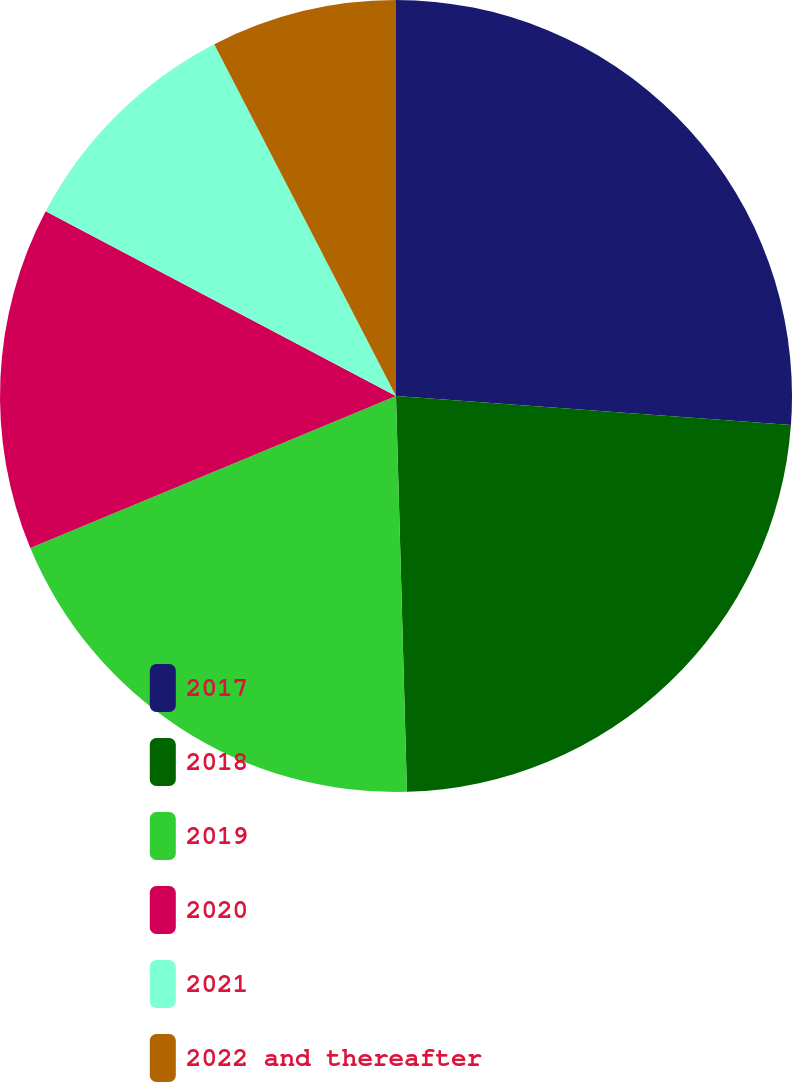Convert chart to OTSL. <chart><loc_0><loc_0><loc_500><loc_500><pie_chart><fcel>2017<fcel>2018<fcel>2019<fcel>2020<fcel>2021<fcel>2022 and thereafter<nl><fcel>26.17%<fcel>23.39%<fcel>19.17%<fcel>13.99%<fcel>9.69%<fcel>7.59%<nl></chart> 